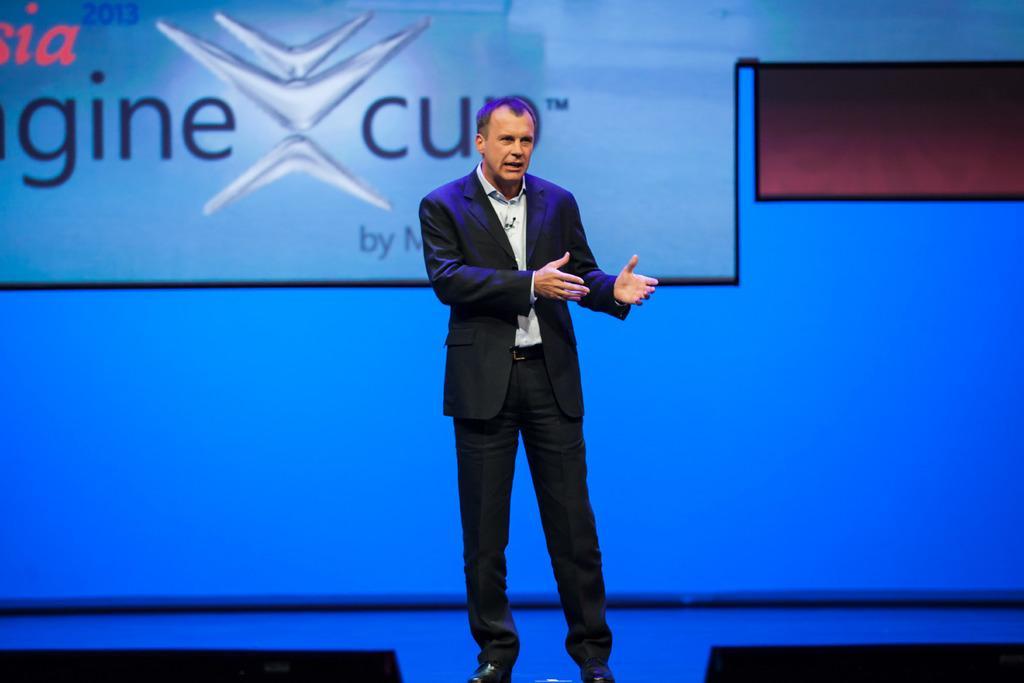Please provide a concise description of this image. In the center of the image there is a person. Behind him there is a screen. 